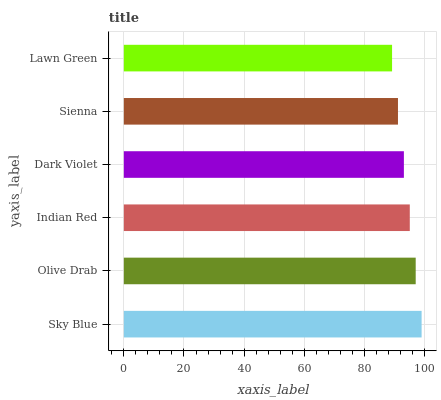Is Lawn Green the minimum?
Answer yes or no. Yes. Is Sky Blue the maximum?
Answer yes or no. Yes. Is Olive Drab the minimum?
Answer yes or no. No. Is Olive Drab the maximum?
Answer yes or no. No. Is Sky Blue greater than Olive Drab?
Answer yes or no. Yes. Is Olive Drab less than Sky Blue?
Answer yes or no. Yes. Is Olive Drab greater than Sky Blue?
Answer yes or no. No. Is Sky Blue less than Olive Drab?
Answer yes or no. No. Is Indian Red the high median?
Answer yes or no. Yes. Is Dark Violet the low median?
Answer yes or no. Yes. Is Olive Drab the high median?
Answer yes or no. No. Is Indian Red the low median?
Answer yes or no. No. 